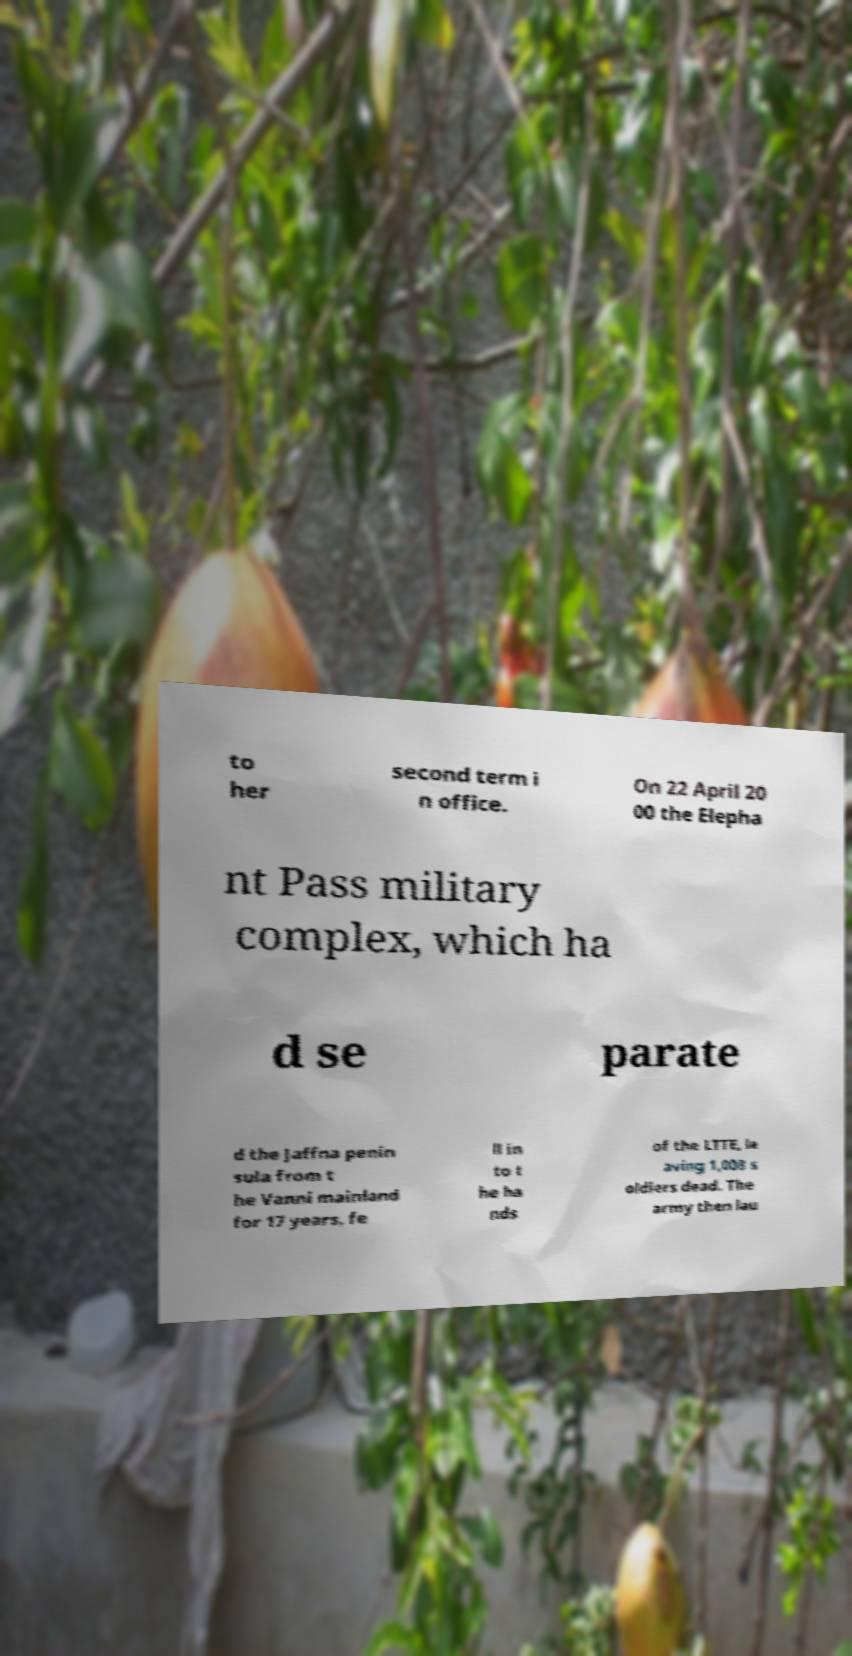Can you accurately transcribe the text from the provided image for me? to her second term i n office. On 22 April 20 00 the Elepha nt Pass military complex, which ha d se parate d the Jaffna penin sula from t he Vanni mainland for 17 years, fe ll in to t he ha nds of the LTTE, le aving 1,008 s oldiers dead. The army then lau 